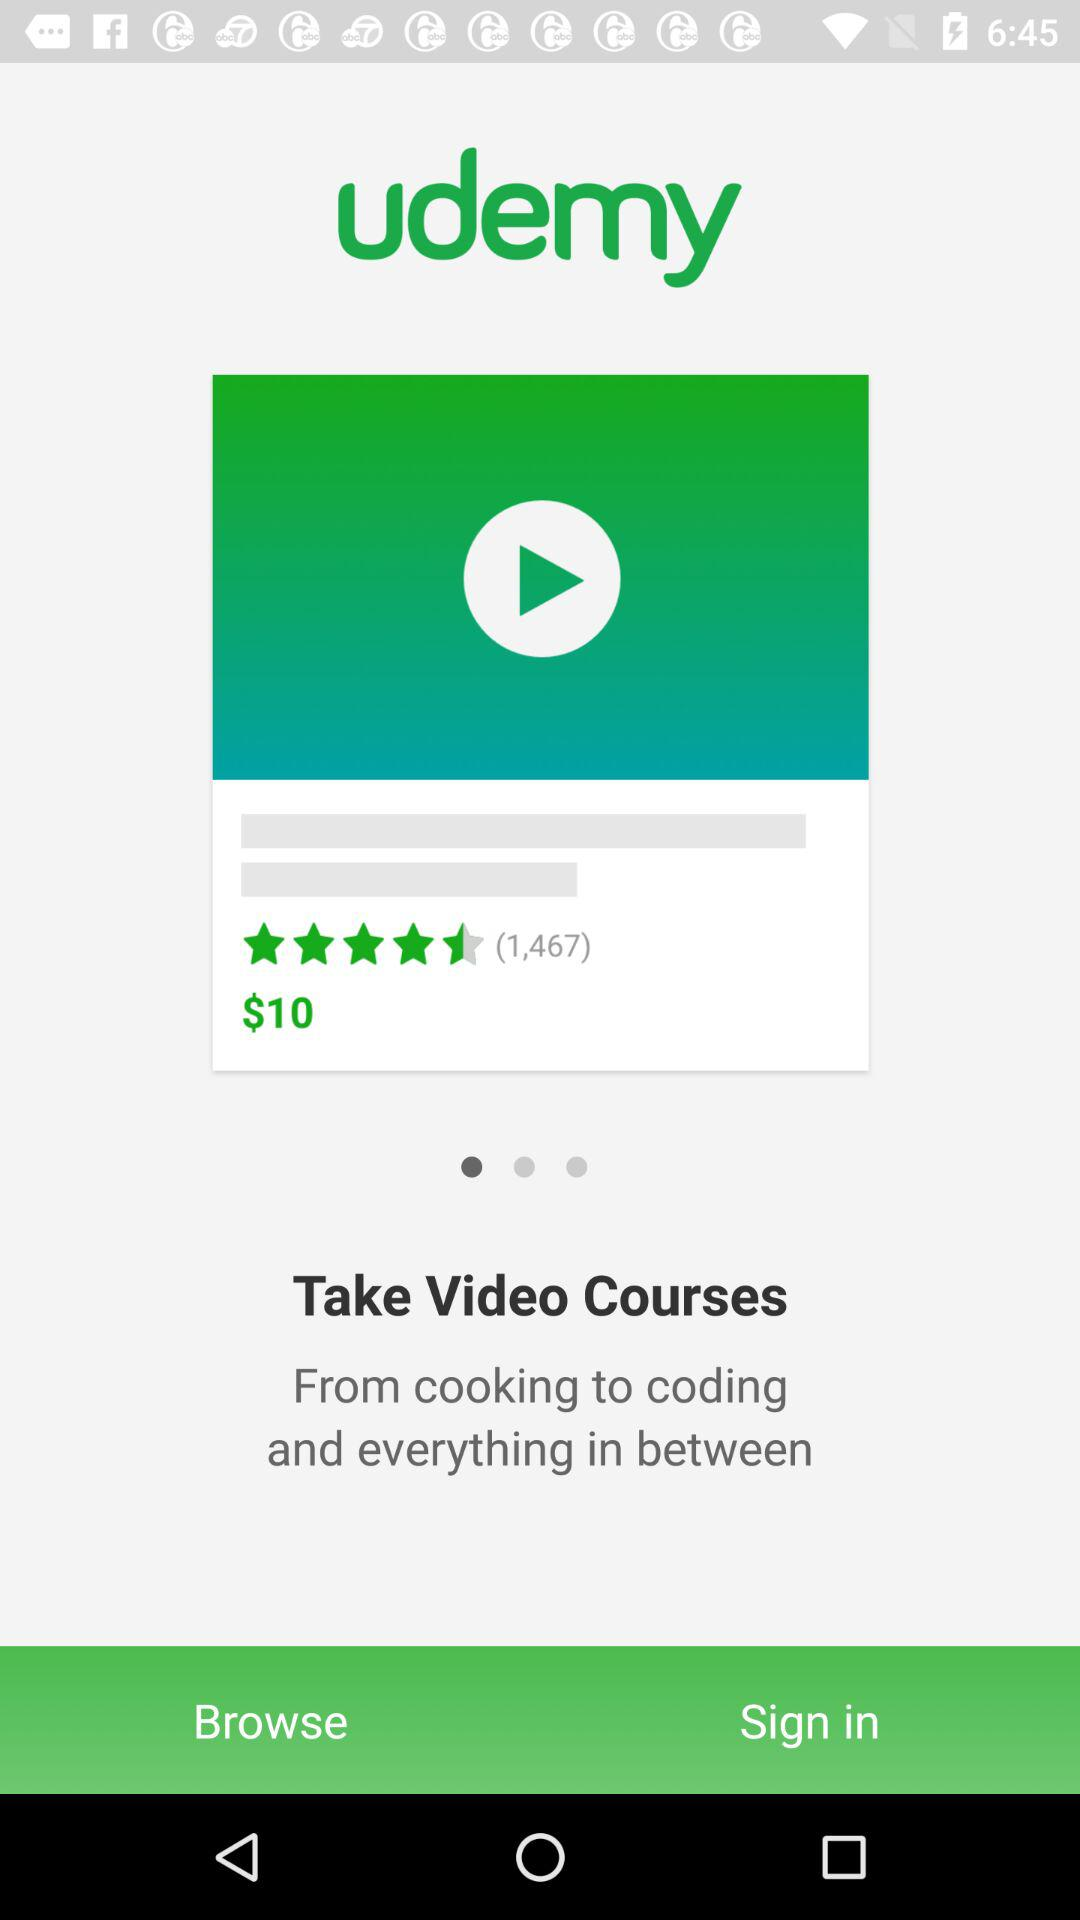What is the price? The price is $10. 